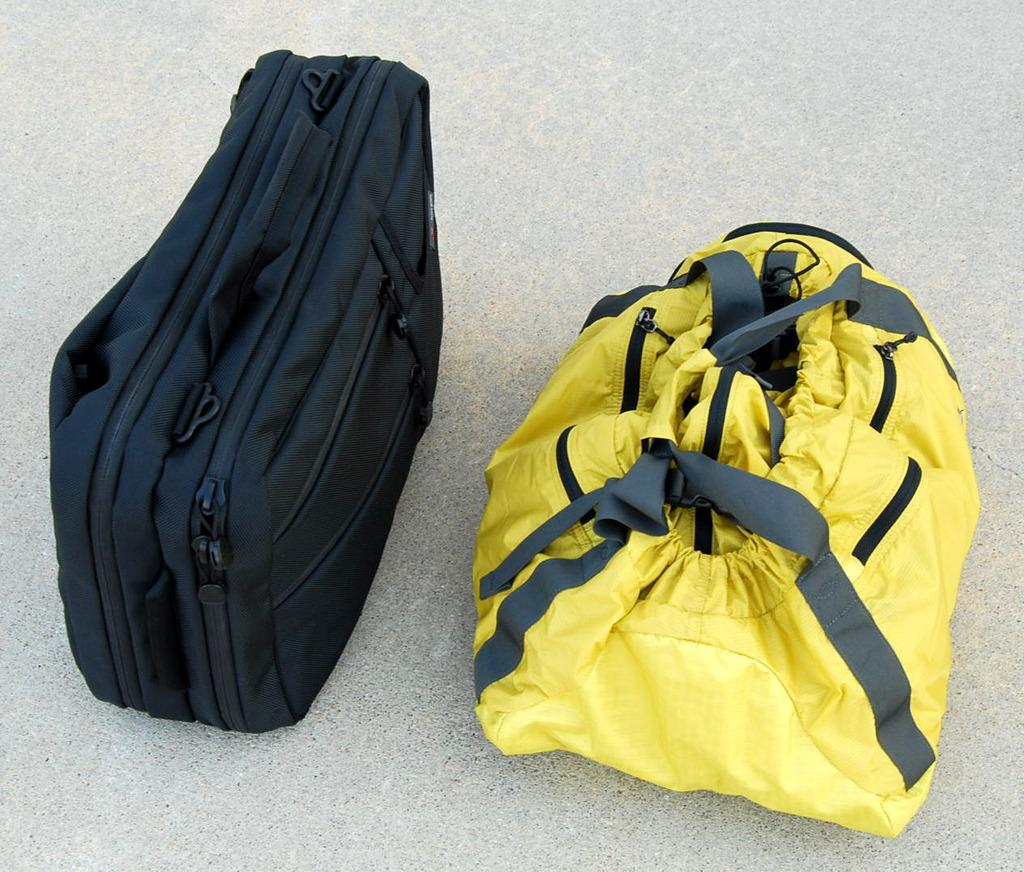How many bags are visible in the image? There are two bags in the image. Where are the bags located? The bags are on a surface. What type of riddle is written on the bags in the image? There is no riddle written on the bags in the image. What substance is being used as fuel for the bags in the image? There is no substance being used as fuel for the bags in the image, as bags do not require fuel to function. 